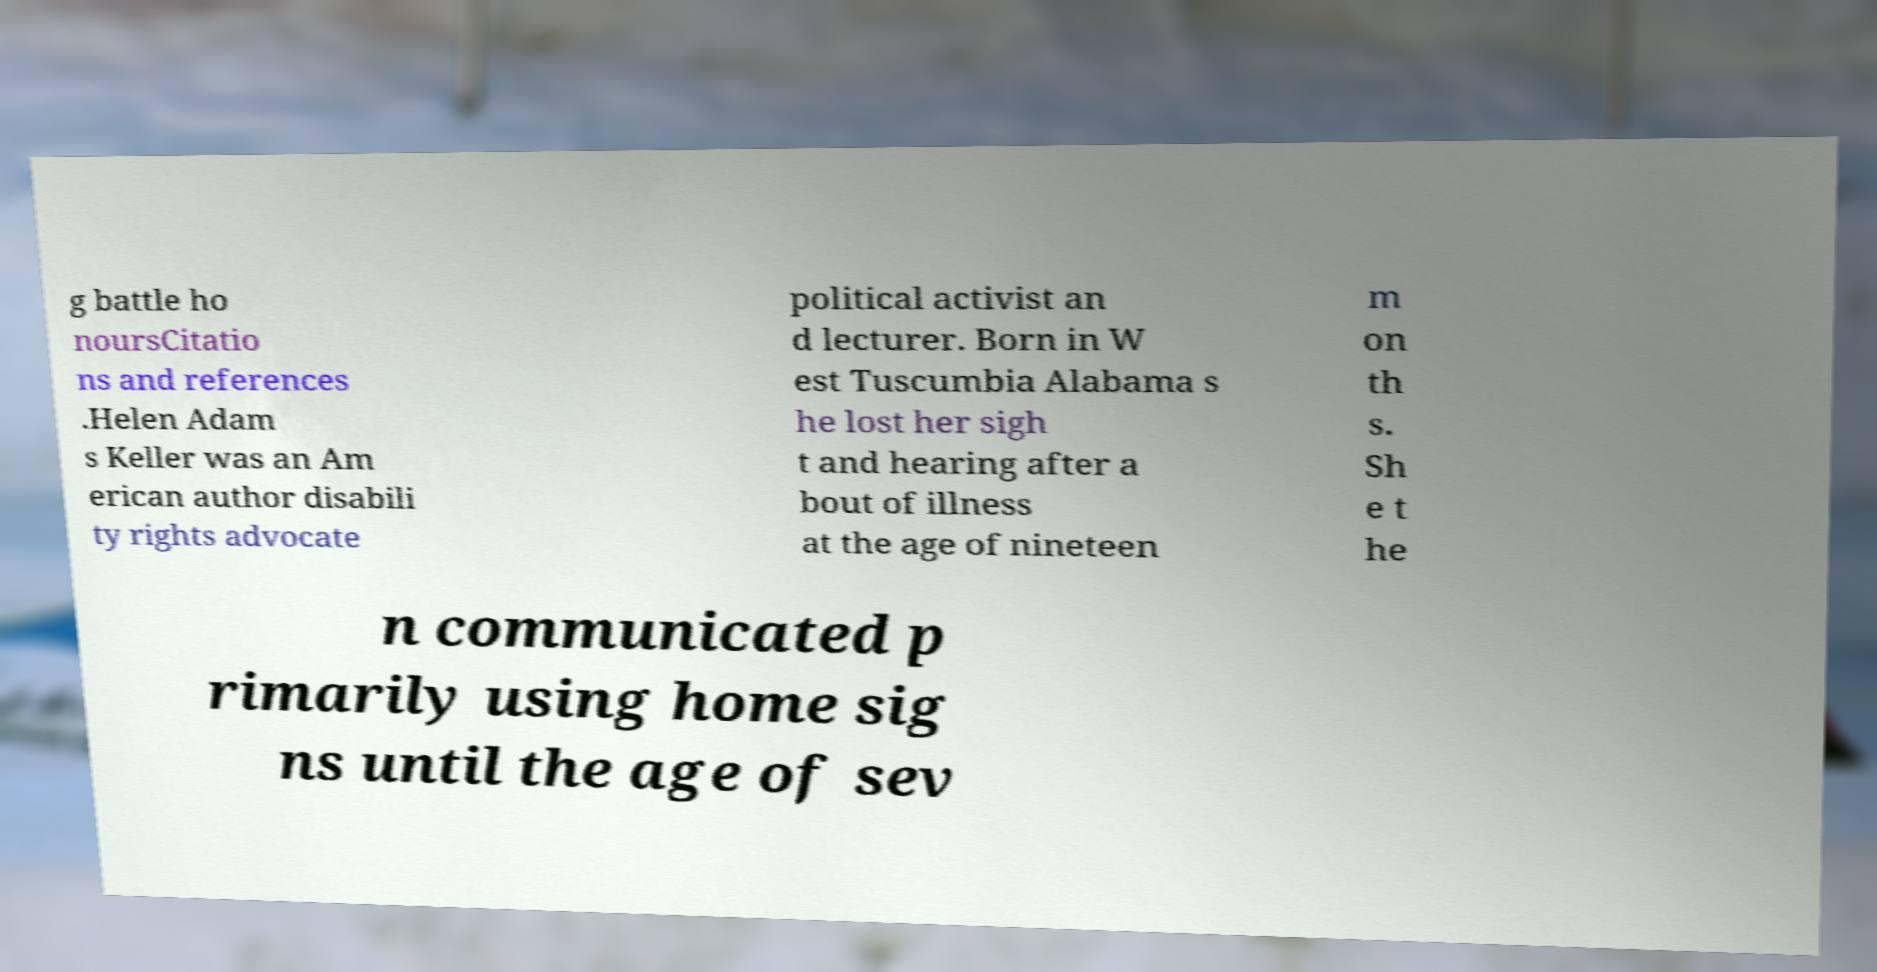What messages or text are displayed in this image? I need them in a readable, typed format. g battle ho noursCitatio ns and references .Helen Adam s Keller was an Am erican author disabili ty rights advocate political activist an d lecturer. Born in W est Tuscumbia Alabama s he lost her sigh t and hearing after a bout of illness at the age of nineteen m on th s. Sh e t he n communicated p rimarily using home sig ns until the age of sev 